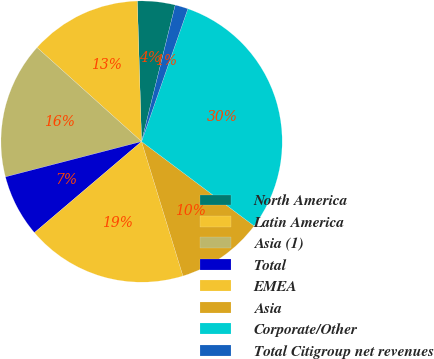Convert chart. <chart><loc_0><loc_0><loc_500><loc_500><pie_chart><fcel>North America<fcel>Latin America<fcel>Asia (1)<fcel>Total<fcel>EMEA<fcel>Asia<fcel>Corporate/Other<fcel>Total Citigroup net revenues<nl><fcel>4.33%<fcel>12.86%<fcel>15.7%<fcel>7.17%<fcel>18.54%<fcel>10.01%<fcel>29.9%<fcel>1.49%<nl></chart> 